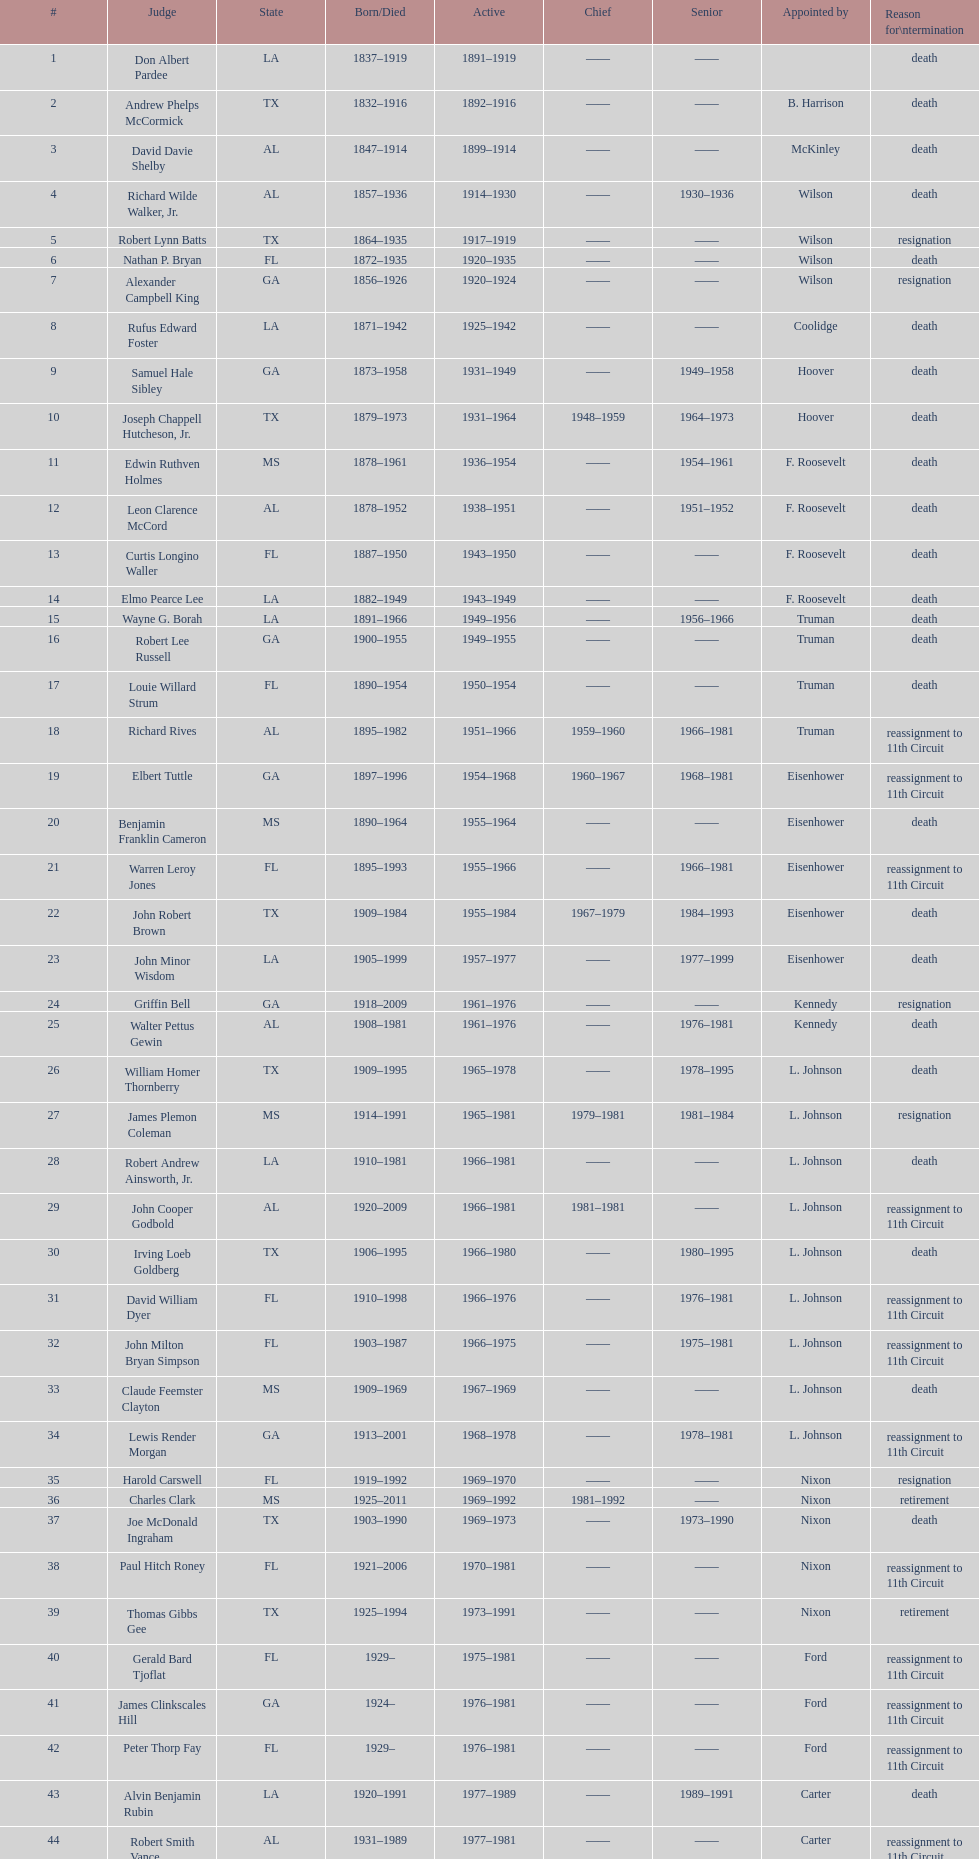Which judge was last appointed by president truman? Richard Rives. 